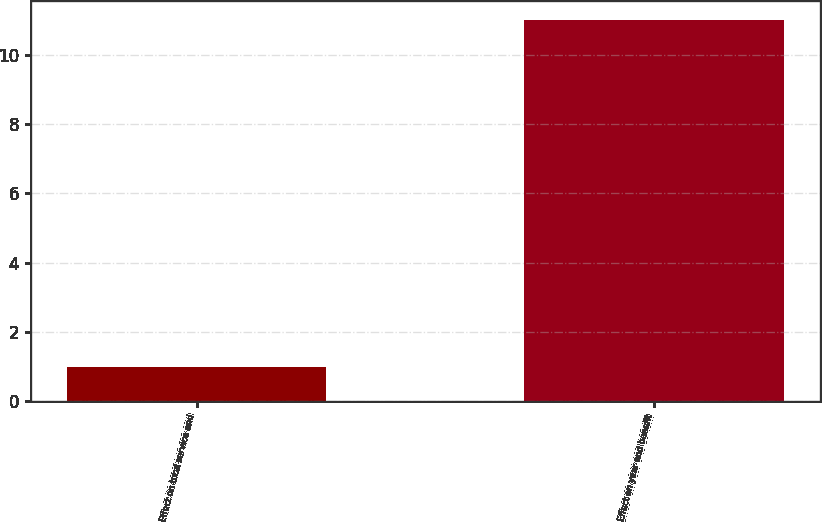Convert chart to OTSL. <chart><loc_0><loc_0><loc_500><loc_500><bar_chart><fcel>Effect on total service and<fcel>Effect on year end benefit<nl><fcel>1<fcel>11<nl></chart> 